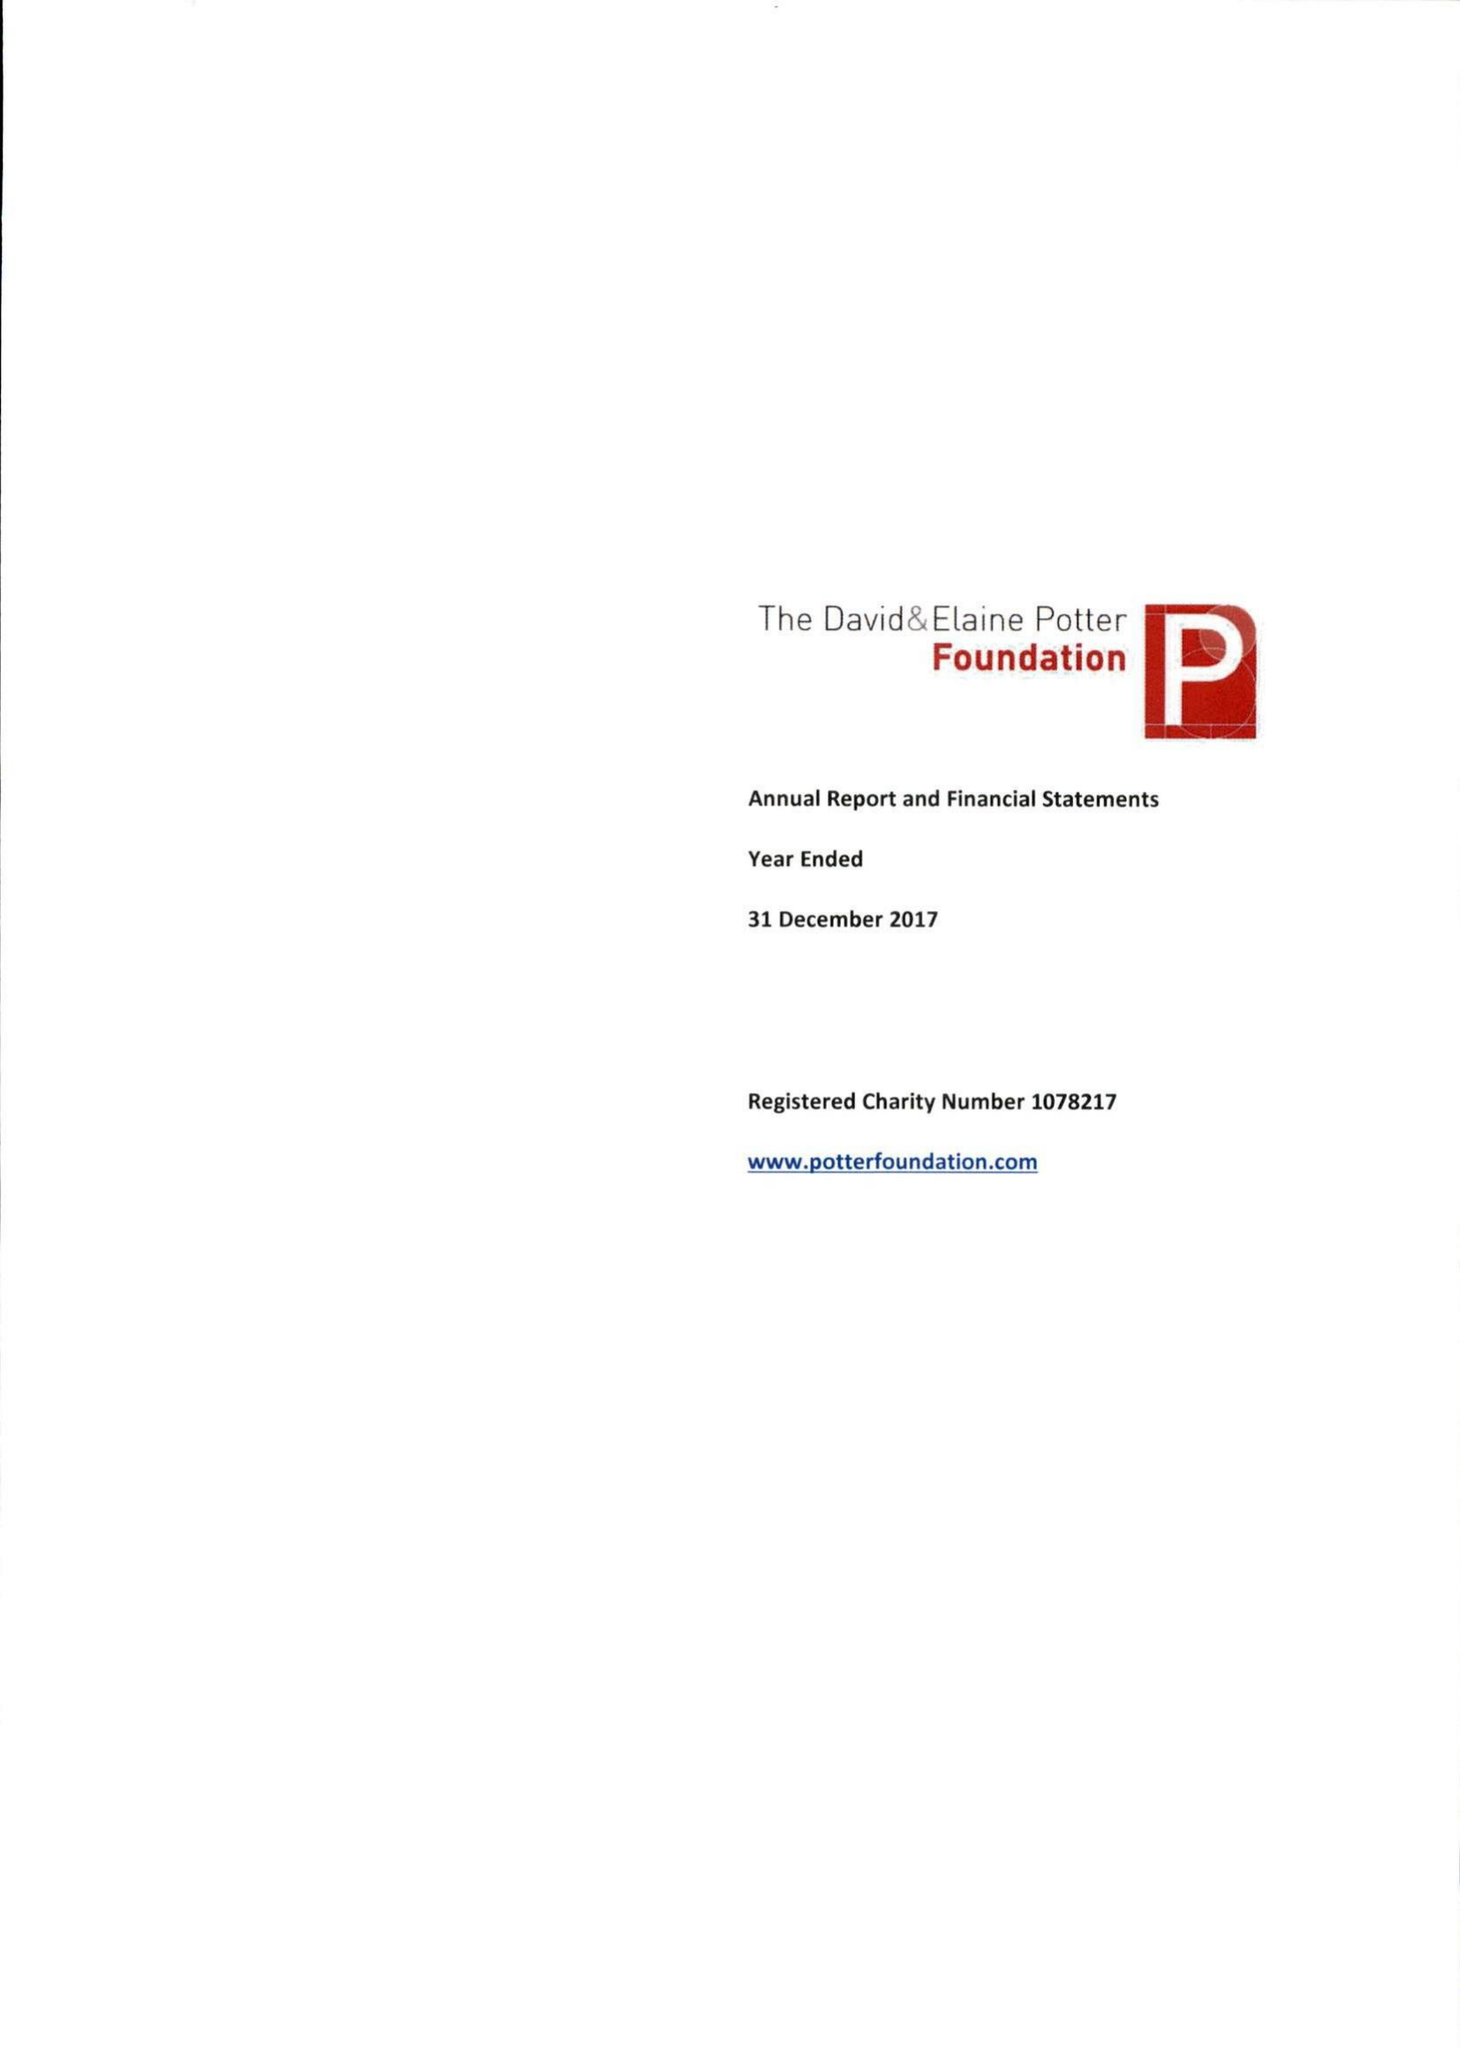What is the value for the charity_name?
Answer the question using a single word or phrase. David and Elaine Potter Foundation 